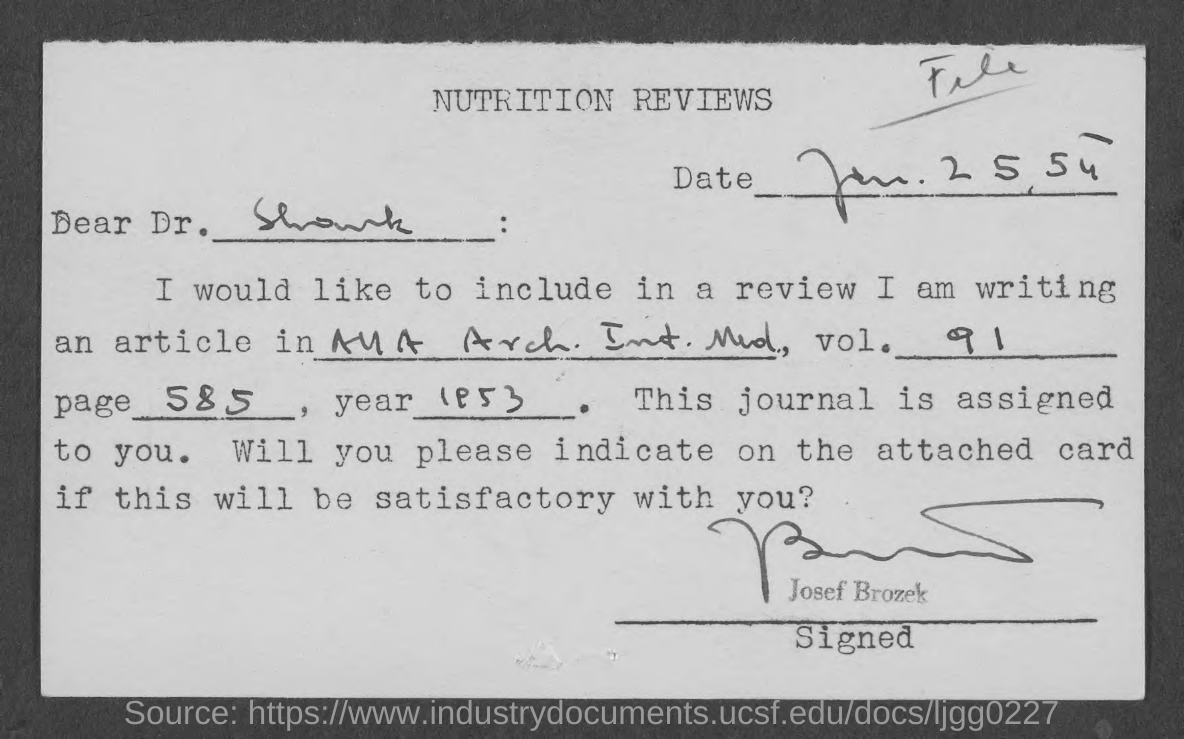Specify some key components in this picture. This document pertains to the topic of NUTRITION REVIEWS. The article's volume number is 91. The document is addressed to Dr. Shank. According to the document, the date mentioned is January 25, 1954. The document has been signed by Josef Brozek. 